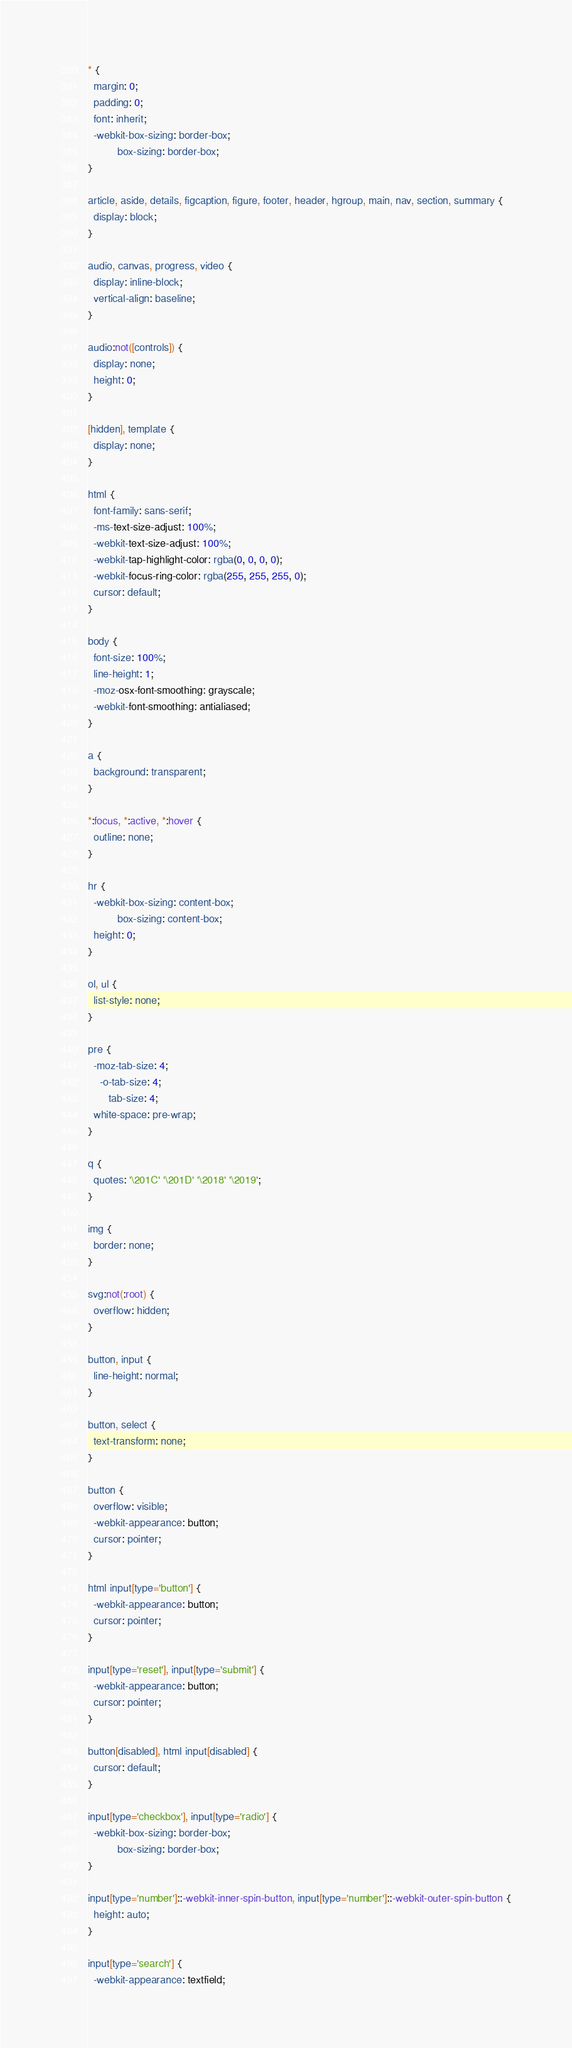<code> <loc_0><loc_0><loc_500><loc_500><_CSS_>* {
  margin: 0;
  padding: 0;
  font: inherit;
  -webkit-box-sizing: border-box;
          box-sizing: border-box;
}

article, aside, details, figcaption, figure, footer, header, hgroup, main, nav, section, summary {
  display: block;
}

audio, canvas, progress, video {
  display: inline-block;
  vertical-align: baseline;
}

audio:not([controls]) {
  display: none;
  height: 0;
}

[hidden], template {
  display: none;
}

html {
  font-family: sans-serif;
  -ms-text-size-adjust: 100%;
  -webkit-text-size-adjust: 100%;
  -webkit-tap-highlight-color: rgba(0, 0, 0, 0);
  -webkit-focus-ring-color: rgba(255, 255, 255, 0);
  cursor: default;
}

body {
  font-size: 100%;
  line-height: 1;
  -moz-osx-font-smoothing: grayscale;
  -webkit-font-smoothing: antialiased;
}

a {
  background: transparent;
}

*:focus, *:active, *:hover {
  outline: none;
}

hr {
  -webkit-box-sizing: content-box;
          box-sizing: content-box;
  height: 0;
}

ol, ul {
  list-style: none;
}

pre {
  -moz-tab-size: 4;
    -o-tab-size: 4;
       tab-size: 4;
  white-space: pre-wrap;
}

q {
  quotes: '\201C' '\201D' '\2018' '\2019';
}

img {
  border: none;
}

svg:not(:root) {
  overflow: hidden;
}

button, input {
  line-height: normal;
}

button, select {
  text-transform: none;
}

button {
  overflow: visible;
  -webkit-appearance: button;
  cursor: pointer;
}

html input[type='button'] {
  -webkit-appearance: button;
  cursor: pointer;
}

input[type='reset'], input[type='submit'] {
  -webkit-appearance: button;
  cursor: pointer;
}

button[disabled], html input[disabled] {
  cursor: default;
}

input[type='checkbox'], input[type='radio'] {
  -webkit-box-sizing: border-box;
          box-sizing: border-box;
}

input[type='number']::-webkit-inner-spin-button, input[type='number']::-webkit-outer-spin-button {
  height: auto;
}

input[type='search'] {
  -webkit-appearance: textfield;</code> 